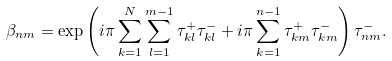Convert formula to latex. <formula><loc_0><loc_0><loc_500><loc_500>\beta _ { n m } = \exp \left ( i \pi \sum ^ { N } _ { k = 1 } \sum ^ { m - 1 } _ { l = 1 } \tau ^ { + } _ { k l } \tau ^ { - } _ { k l } + i \pi \sum ^ { n - 1 } _ { k = 1 } \tau ^ { + } _ { k m } \tau ^ { - } _ { k m } \right ) \tau ^ { - } _ { n m } .</formula> 